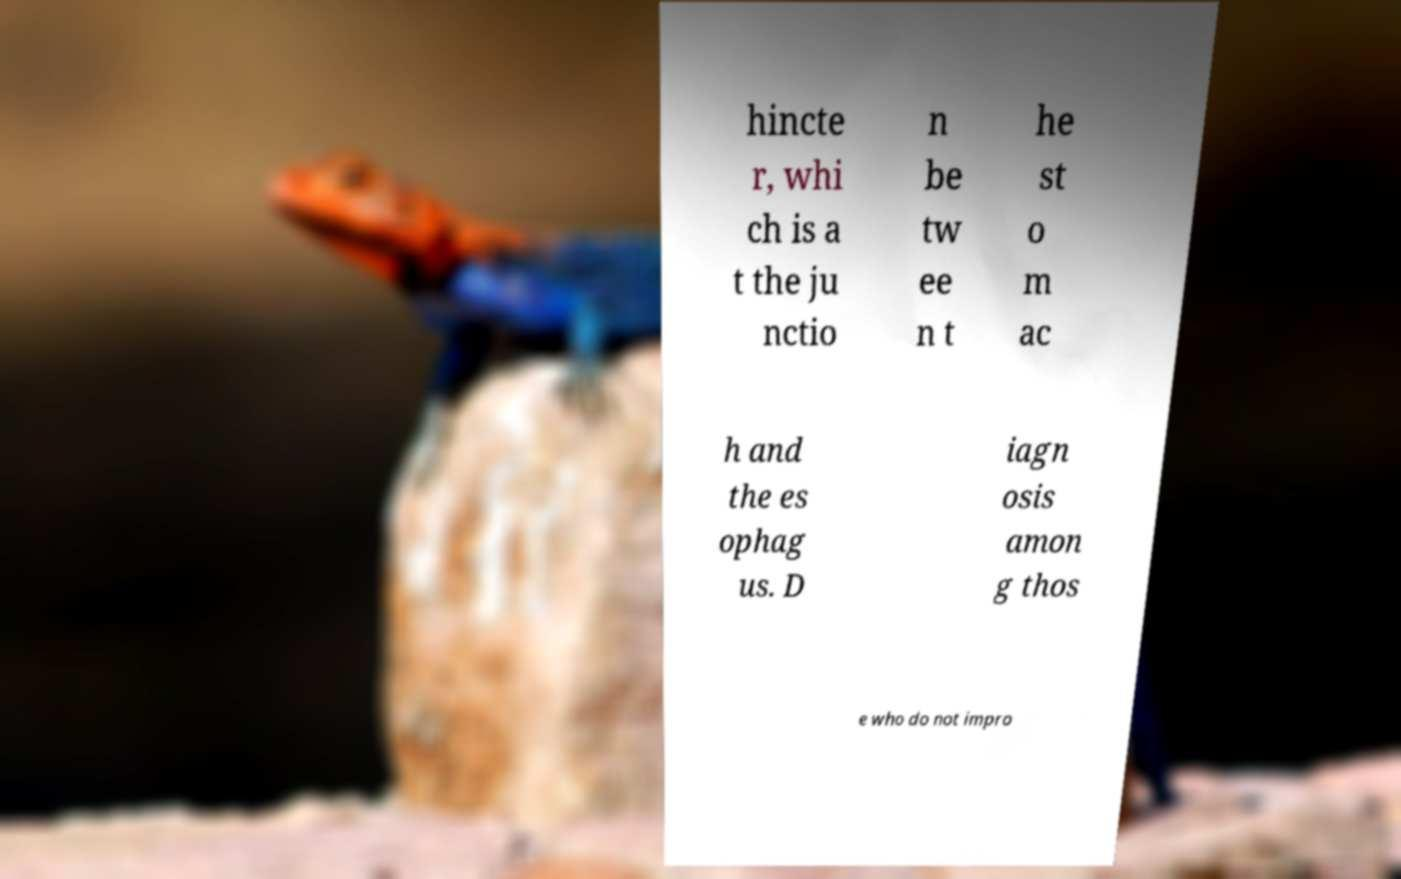Could you extract and type out the text from this image? hincte r, whi ch is a t the ju nctio n be tw ee n t he st o m ac h and the es ophag us. D iagn osis amon g thos e who do not impro 